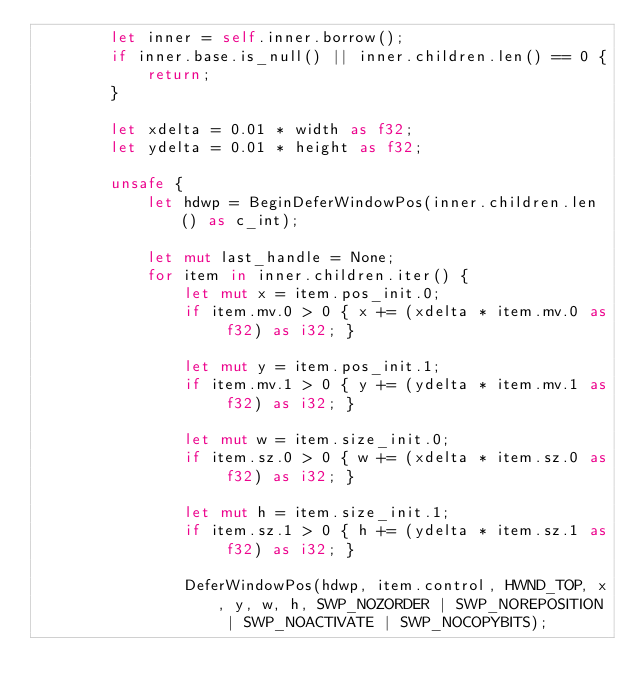<code> <loc_0><loc_0><loc_500><loc_500><_Rust_>        let inner = self.inner.borrow();
        if inner.base.is_null() || inner.children.len() == 0 {
            return;
        }

        let xdelta = 0.01 * width as f32;
        let ydelta = 0.01 * height as f32;

        unsafe {
            let hdwp = BeginDeferWindowPos(inner.children.len() as c_int);

            let mut last_handle = None;
            for item in inner.children.iter() {
                let mut x = item.pos_init.0;
                if item.mv.0 > 0 { x += (xdelta * item.mv.0 as f32) as i32; }

                let mut y = item.pos_init.1;
                if item.mv.1 > 0 { y += (ydelta * item.mv.1 as f32) as i32; }

                let mut w = item.size_init.0;
                if item.sz.0 > 0 { w += (xdelta * item.sz.0 as f32) as i32; }

                let mut h = item.size_init.1;
                if item.sz.1 > 0 { h += (ydelta * item.sz.1 as f32) as i32; }

                DeferWindowPos(hdwp, item.control, HWND_TOP, x, y, w, h, SWP_NOZORDER | SWP_NOREPOSITION | SWP_NOACTIVATE | SWP_NOCOPYBITS);
</code> 